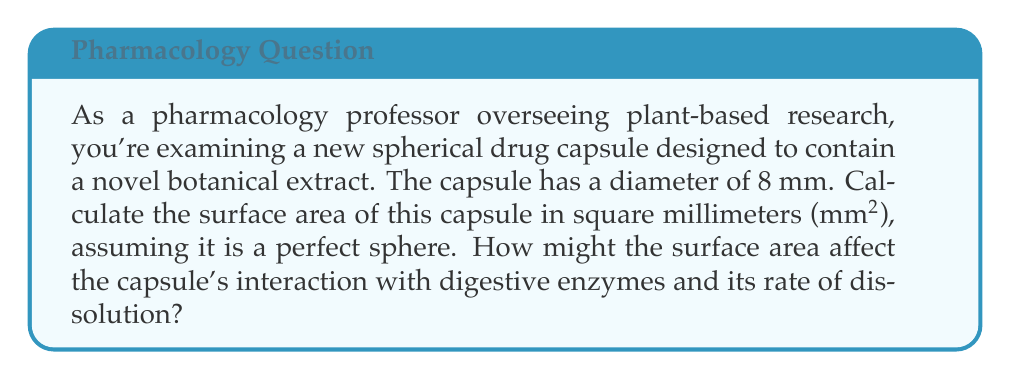Can you answer this question? To calculate the surface area of a spherical drug capsule, we use the formula for the surface area of a sphere:

$$A = 4\pi r^2$$

Where:
$A$ = surface area
$r$ = radius of the sphere

Given:
- Diameter of the capsule = 8 mm
- Radius = Diameter ÷ 2 = 8 mm ÷ 2 = 4 mm

Step 1: Substitute the radius into the formula
$$A = 4\pi (4\text{ mm})^2$$

Step 2: Calculate the square of the radius
$$A = 4\pi (16\text{ mm}^2)$$

Step 3: Multiply by $4\pi$
$$A = 64\pi\text{ mm}^2$$

Step 4: Calculate the final value (rounded to two decimal places)
$$A = 201.06\text{ mm}^2$$

The surface area of the spherical drug capsule is approximately 201.06 mm².

Regarding the capsule's interaction with digestive enzymes and its rate of dissolution:

1. A larger surface area increases the contact between the capsule and digestive enzymes, potentially leading to faster breakdown of the capsule material.
2. The increased surface area also allows for more rapid dissolution of the capsule contents, as there is more area for the surrounding liquid to interact with the capsule.
3. These factors may result in faster release of the botanical extract, which could impact its bioavailability and effectiveness.

[asy]
import geometry;

size(100);
draw(circle((0,0),4));
draw((0,0)--(4,0),arrow=Arrow(TeXHead));
label("4 mm", (2,-0.5), S);
label("8 mm", (-4.5,0), W);
draw((-4,0)--(4,0),dashed);
[/asy]
Answer: The surface area of the spherical drug capsule is 201.06 mm². 